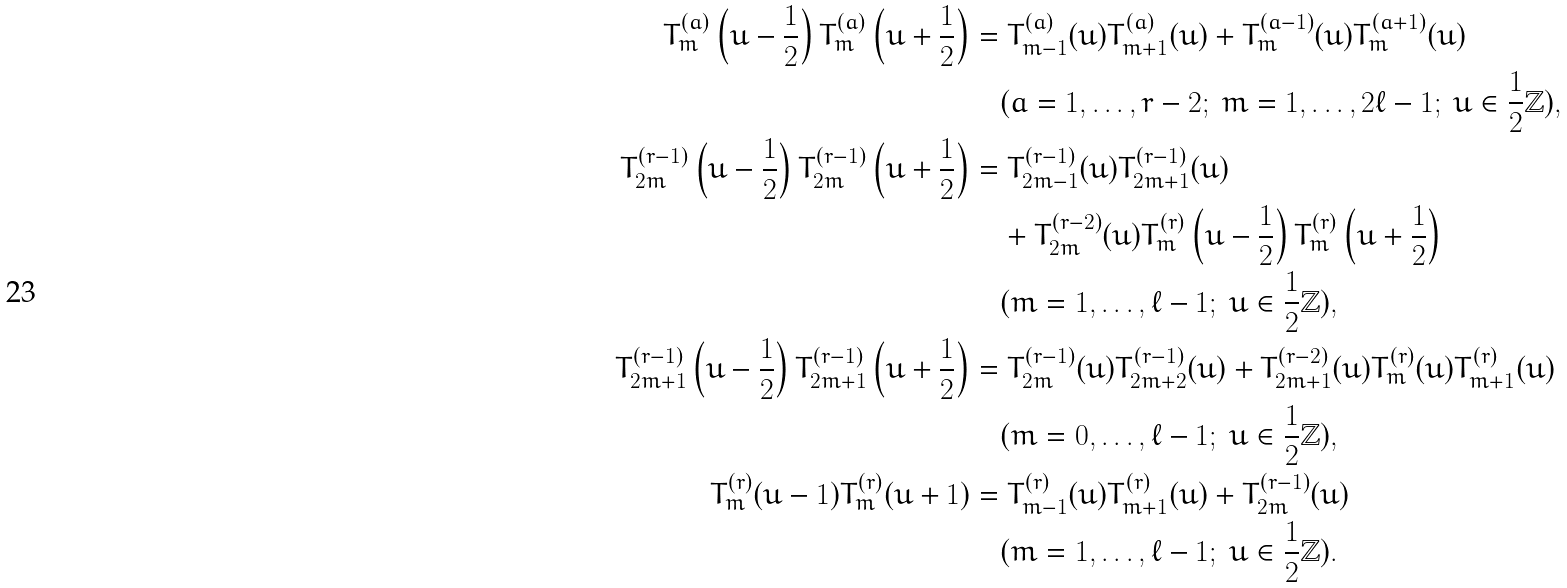Convert formula to latex. <formula><loc_0><loc_0><loc_500><loc_500>T ^ { ( a ) } _ { m } \left ( u - \frac { 1 } { 2 } \right ) T ^ { ( a ) } _ { m } \left ( u + \frac { 1 } { 2 } \right ) & = T ^ { ( a ) } _ { m - 1 } ( u ) T ^ { ( a ) } _ { m + 1 } ( u ) + T ^ { ( a - 1 ) } _ { m } ( u ) T ^ { ( a + 1 ) } _ { m } ( u ) \\ & \quad ( a = 1 , \dots , r - 2 ; \ m = 1 , \dots , 2 \ell - 1 ; \ u \in \frac { 1 } { 2 } \mathbb { Z } ) , \\ T ^ { ( r - 1 ) } _ { 2 m } \left ( u - \frac { 1 } { 2 } \right ) T ^ { ( r - 1 ) } _ { 2 m } \left ( u + \frac { 1 } { 2 } \right ) & = T ^ { ( r - 1 ) } _ { 2 m - 1 } ( u ) T ^ { ( r - 1 ) } _ { 2 m + 1 } ( u ) \\ & \quad + T ^ { ( r - 2 ) } _ { 2 m } ( u ) T ^ { ( r ) } _ { m } \left ( u - \frac { 1 } { 2 } \right ) T ^ { ( r ) } _ { m } \left ( u + \frac { 1 } { 2 } \right ) \\ & \quad ( m = 1 , \dots , \ell - 1 ; \ u \in \frac { 1 } { 2 } \mathbb { Z } ) , \\ T ^ { ( r - 1 ) } _ { 2 m + 1 } \left ( u - \frac { 1 } { 2 } \right ) T ^ { ( r - 1 ) } _ { 2 m + 1 } \left ( u + \frac { 1 } { 2 } \right ) & = T ^ { ( r - 1 ) } _ { 2 m } ( u ) T ^ { ( r - 1 ) } _ { 2 m + 2 } ( u ) + T ^ { ( r - 2 ) } _ { 2 m + 1 } ( u ) T ^ { ( r ) } _ { m } ( u ) T ^ { ( r ) } _ { m + 1 } ( u ) \\ & \quad ( m = 0 , \dots , \ell - 1 ; \ u \in \frac { 1 } { 2 } \mathbb { Z } ) , \\ T ^ { ( r ) } _ { m } ( u - 1 ) T ^ { ( r ) } _ { m } ( u + 1 ) & = T ^ { ( r ) } _ { m - 1 } ( u ) T ^ { ( r ) } _ { m + 1 } ( u ) + T ^ { ( r - 1 ) } _ { 2 m } ( u ) \\ & \quad ( m = 1 , \dots , \ell - 1 ; \ u \in \frac { 1 } { 2 } \mathbb { Z } ) .</formula> 